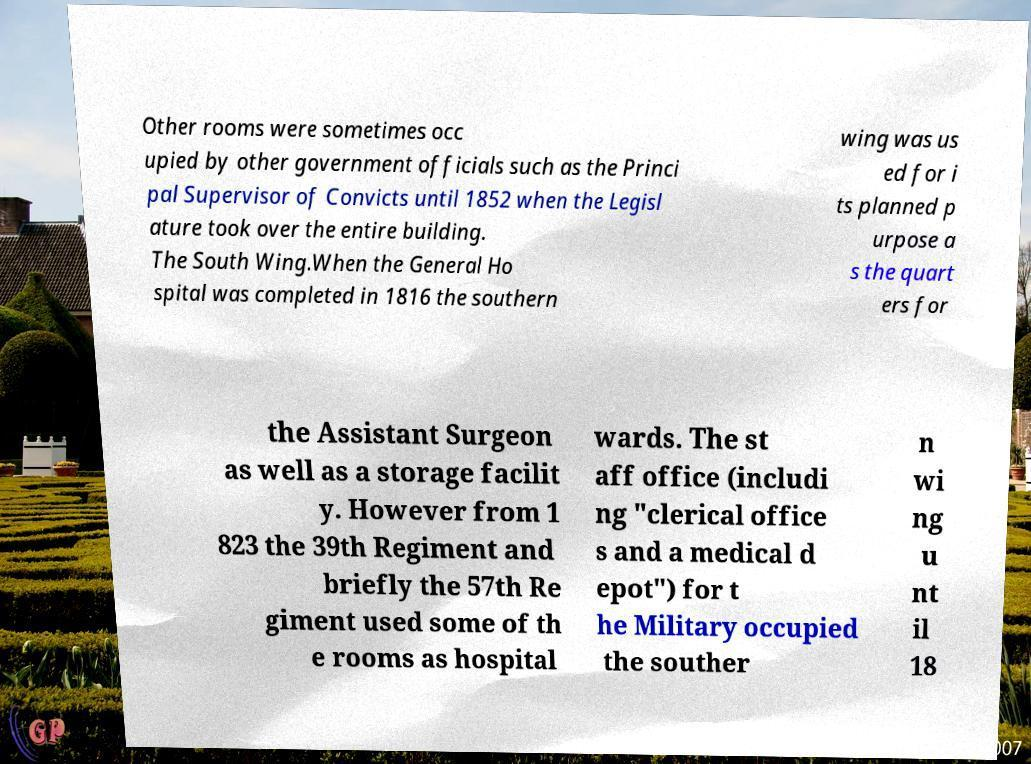What messages or text are displayed in this image? I need them in a readable, typed format. Other rooms were sometimes occ upied by other government officials such as the Princi pal Supervisor of Convicts until 1852 when the Legisl ature took over the entire building. The South Wing.When the General Ho spital was completed in 1816 the southern wing was us ed for i ts planned p urpose a s the quart ers for the Assistant Surgeon as well as a storage facilit y. However from 1 823 the 39th Regiment and briefly the 57th Re giment used some of th e rooms as hospital wards. The st aff office (includi ng "clerical office s and a medical d epot") for t he Military occupied the souther n wi ng u nt il 18 